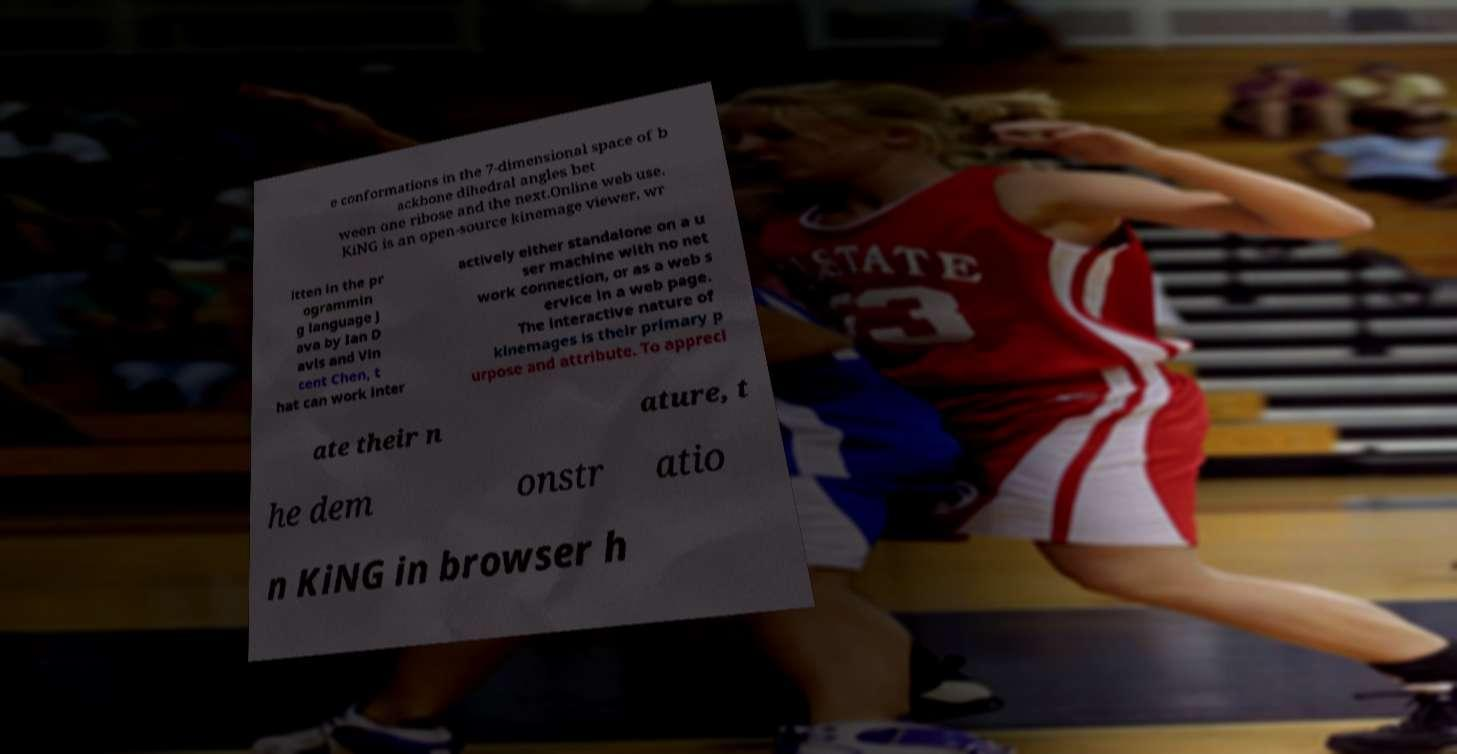For documentation purposes, I need the text within this image transcribed. Could you provide that? e conformations in the 7-dimensional space of b ackbone dihedral angles bet ween one ribose and the next.Online web use. KiNG is an open-source kinemage viewer, wr itten in the pr ogrammin g language J ava by Ian D avis and Vin cent Chen, t hat can work inter actively either standalone on a u ser machine with no net work connection, or as a web s ervice in a web page. The interactive nature of kinemages is their primary p urpose and attribute. To appreci ate their n ature, t he dem onstr atio n KiNG in browser h 